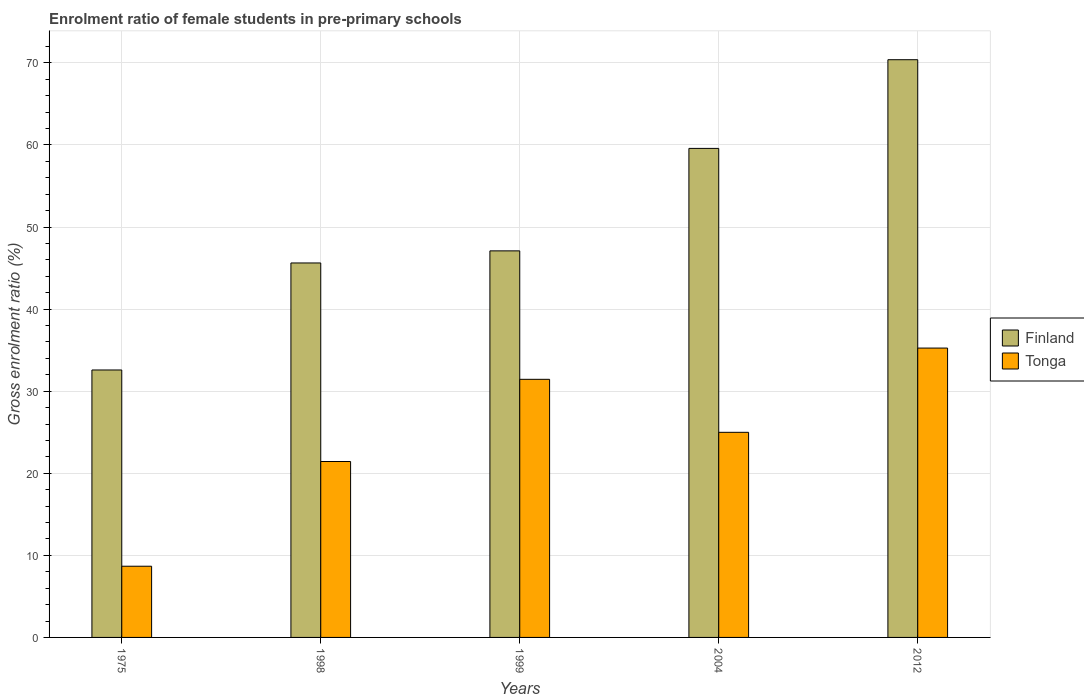How many groups of bars are there?
Give a very brief answer. 5. How many bars are there on the 1st tick from the left?
Provide a succinct answer. 2. How many bars are there on the 5th tick from the right?
Offer a very short reply. 2. What is the label of the 3rd group of bars from the left?
Give a very brief answer. 1999. What is the enrolment ratio of female students in pre-primary schools in Finland in 2004?
Your response must be concise. 59.58. Across all years, what is the maximum enrolment ratio of female students in pre-primary schools in Finland?
Provide a succinct answer. 70.39. Across all years, what is the minimum enrolment ratio of female students in pre-primary schools in Tonga?
Give a very brief answer. 8.67. In which year was the enrolment ratio of female students in pre-primary schools in Tonga minimum?
Ensure brevity in your answer.  1975. What is the total enrolment ratio of female students in pre-primary schools in Tonga in the graph?
Make the answer very short. 121.8. What is the difference between the enrolment ratio of female students in pre-primary schools in Finland in 1999 and that in 2012?
Provide a short and direct response. -23.29. What is the difference between the enrolment ratio of female students in pre-primary schools in Finland in 2012 and the enrolment ratio of female students in pre-primary schools in Tonga in 1999?
Provide a short and direct response. 38.94. What is the average enrolment ratio of female students in pre-primary schools in Tonga per year?
Keep it short and to the point. 24.36. In the year 1998, what is the difference between the enrolment ratio of female students in pre-primary schools in Tonga and enrolment ratio of female students in pre-primary schools in Finland?
Make the answer very short. -24.19. What is the ratio of the enrolment ratio of female students in pre-primary schools in Finland in 1975 to that in 1999?
Ensure brevity in your answer.  0.69. Is the enrolment ratio of female students in pre-primary schools in Finland in 1999 less than that in 2004?
Ensure brevity in your answer.  Yes. What is the difference between the highest and the second highest enrolment ratio of female students in pre-primary schools in Tonga?
Your answer should be compact. 3.81. What is the difference between the highest and the lowest enrolment ratio of female students in pre-primary schools in Tonga?
Offer a terse response. 26.58. In how many years, is the enrolment ratio of female students in pre-primary schools in Finland greater than the average enrolment ratio of female students in pre-primary schools in Finland taken over all years?
Your answer should be compact. 2. Is the sum of the enrolment ratio of female students in pre-primary schools in Finland in 1998 and 1999 greater than the maximum enrolment ratio of female students in pre-primary schools in Tonga across all years?
Your answer should be compact. Yes. What does the 2nd bar from the left in 1998 represents?
Your answer should be very brief. Tonga. Are all the bars in the graph horizontal?
Your answer should be very brief. No. What is the difference between two consecutive major ticks on the Y-axis?
Give a very brief answer. 10. Does the graph contain grids?
Your answer should be compact. Yes. How many legend labels are there?
Provide a short and direct response. 2. What is the title of the graph?
Give a very brief answer. Enrolment ratio of female students in pre-primary schools. Does "Macedonia" appear as one of the legend labels in the graph?
Ensure brevity in your answer.  No. What is the label or title of the Y-axis?
Ensure brevity in your answer.  Gross enrolment ratio (%). What is the Gross enrolment ratio (%) of Finland in 1975?
Make the answer very short. 32.59. What is the Gross enrolment ratio (%) of Tonga in 1975?
Offer a very short reply. 8.67. What is the Gross enrolment ratio (%) of Finland in 1998?
Ensure brevity in your answer.  45.63. What is the Gross enrolment ratio (%) of Tonga in 1998?
Offer a terse response. 21.43. What is the Gross enrolment ratio (%) in Finland in 1999?
Your answer should be compact. 47.1. What is the Gross enrolment ratio (%) in Tonga in 1999?
Offer a very short reply. 31.45. What is the Gross enrolment ratio (%) of Finland in 2004?
Provide a short and direct response. 59.58. What is the Gross enrolment ratio (%) of Tonga in 2004?
Keep it short and to the point. 24.99. What is the Gross enrolment ratio (%) in Finland in 2012?
Your answer should be compact. 70.39. What is the Gross enrolment ratio (%) of Tonga in 2012?
Your response must be concise. 35.26. Across all years, what is the maximum Gross enrolment ratio (%) in Finland?
Make the answer very short. 70.39. Across all years, what is the maximum Gross enrolment ratio (%) in Tonga?
Your answer should be very brief. 35.26. Across all years, what is the minimum Gross enrolment ratio (%) in Finland?
Provide a succinct answer. 32.59. Across all years, what is the minimum Gross enrolment ratio (%) in Tonga?
Your response must be concise. 8.67. What is the total Gross enrolment ratio (%) of Finland in the graph?
Give a very brief answer. 255.28. What is the total Gross enrolment ratio (%) of Tonga in the graph?
Your answer should be compact. 121.8. What is the difference between the Gross enrolment ratio (%) of Finland in 1975 and that in 1998?
Offer a very short reply. -13.04. What is the difference between the Gross enrolment ratio (%) in Tonga in 1975 and that in 1998?
Give a very brief answer. -12.76. What is the difference between the Gross enrolment ratio (%) of Finland in 1975 and that in 1999?
Offer a very short reply. -14.51. What is the difference between the Gross enrolment ratio (%) in Tonga in 1975 and that in 1999?
Offer a very short reply. -22.77. What is the difference between the Gross enrolment ratio (%) in Finland in 1975 and that in 2004?
Provide a short and direct response. -27. What is the difference between the Gross enrolment ratio (%) of Tonga in 1975 and that in 2004?
Ensure brevity in your answer.  -16.32. What is the difference between the Gross enrolment ratio (%) of Finland in 1975 and that in 2012?
Ensure brevity in your answer.  -37.8. What is the difference between the Gross enrolment ratio (%) of Tonga in 1975 and that in 2012?
Offer a very short reply. -26.58. What is the difference between the Gross enrolment ratio (%) in Finland in 1998 and that in 1999?
Ensure brevity in your answer.  -1.47. What is the difference between the Gross enrolment ratio (%) of Tonga in 1998 and that in 1999?
Keep it short and to the point. -10.01. What is the difference between the Gross enrolment ratio (%) in Finland in 1998 and that in 2004?
Give a very brief answer. -13.96. What is the difference between the Gross enrolment ratio (%) in Tonga in 1998 and that in 2004?
Make the answer very short. -3.56. What is the difference between the Gross enrolment ratio (%) of Finland in 1998 and that in 2012?
Your response must be concise. -24.76. What is the difference between the Gross enrolment ratio (%) of Tonga in 1998 and that in 2012?
Provide a succinct answer. -13.82. What is the difference between the Gross enrolment ratio (%) of Finland in 1999 and that in 2004?
Offer a very short reply. -12.48. What is the difference between the Gross enrolment ratio (%) in Tonga in 1999 and that in 2004?
Ensure brevity in your answer.  6.46. What is the difference between the Gross enrolment ratio (%) in Finland in 1999 and that in 2012?
Keep it short and to the point. -23.29. What is the difference between the Gross enrolment ratio (%) in Tonga in 1999 and that in 2012?
Ensure brevity in your answer.  -3.81. What is the difference between the Gross enrolment ratio (%) in Finland in 2004 and that in 2012?
Provide a short and direct response. -10.81. What is the difference between the Gross enrolment ratio (%) in Tonga in 2004 and that in 2012?
Make the answer very short. -10.27. What is the difference between the Gross enrolment ratio (%) in Finland in 1975 and the Gross enrolment ratio (%) in Tonga in 1998?
Keep it short and to the point. 11.15. What is the difference between the Gross enrolment ratio (%) in Finland in 1975 and the Gross enrolment ratio (%) in Tonga in 1999?
Ensure brevity in your answer.  1.14. What is the difference between the Gross enrolment ratio (%) of Finland in 1975 and the Gross enrolment ratio (%) of Tonga in 2004?
Provide a short and direct response. 7.6. What is the difference between the Gross enrolment ratio (%) in Finland in 1975 and the Gross enrolment ratio (%) in Tonga in 2012?
Make the answer very short. -2.67. What is the difference between the Gross enrolment ratio (%) of Finland in 1998 and the Gross enrolment ratio (%) of Tonga in 1999?
Make the answer very short. 14.18. What is the difference between the Gross enrolment ratio (%) of Finland in 1998 and the Gross enrolment ratio (%) of Tonga in 2004?
Ensure brevity in your answer.  20.64. What is the difference between the Gross enrolment ratio (%) in Finland in 1998 and the Gross enrolment ratio (%) in Tonga in 2012?
Offer a very short reply. 10.37. What is the difference between the Gross enrolment ratio (%) in Finland in 1999 and the Gross enrolment ratio (%) in Tonga in 2004?
Provide a short and direct response. 22.11. What is the difference between the Gross enrolment ratio (%) in Finland in 1999 and the Gross enrolment ratio (%) in Tonga in 2012?
Your response must be concise. 11.84. What is the difference between the Gross enrolment ratio (%) of Finland in 2004 and the Gross enrolment ratio (%) of Tonga in 2012?
Your answer should be compact. 24.33. What is the average Gross enrolment ratio (%) of Finland per year?
Ensure brevity in your answer.  51.06. What is the average Gross enrolment ratio (%) of Tonga per year?
Provide a succinct answer. 24.36. In the year 1975, what is the difference between the Gross enrolment ratio (%) of Finland and Gross enrolment ratio (%) of Tonga?
Offer a terse response. 23.91. In the year 1998, what is the difference between the Gross enrolment ratio (%) in Finland and Gross enrolment ratio (%) in Tonga?
Ensure brevity in your answer.  24.19. In the year 1999, what is the difference between the Gross enrolment ratio (%) of Finland and Gross enrolment ratio (%) of Tonga?
Ensure brevity in your answer.  15.65. In the year 2004, what is the difference between the Gross enrolment ratio (%) in Finland and Gross enrolment ratio (%) in Tonga?
Give a very brief answer. 34.59. In the year 2012, what is the difference between the Gross enrolment ratio (%) in Finland and Gross enrolment ratio (%) in Tonga?
Your response must be concise. 35.13. What is the ratio of the Gross enrolment ratio (%) of Finland in 1975 to that in 1998?
Your response must be concise. 0.71. What is the ratio of the Gross enrolment ratio (%) in Tonga in 1975 to that in 1998?
Provide a short and direct response. 0.4. What is the ratio of the Gross enrolment ratio (%) of Finland in 1975 to that in 1999?
Your answer should be compact. 0.69. What is the ratio of the Gross enrolment ratio (%) of Tonga in 1975 to that in 1999?
Your response must be concise. 0.28. What is the ratio of the Gross enrolment ratio (%) of Finland in 1975 to that in 2004?
Make the answer very short. 0.55. What is the ratio of the Gross enrolment ratio (%) of Tonga in 1975 to that in 2004?
Give a very brief answer. 0.35. What is the ratio of the Gross enrolment ratio (%) in Finland in 1975 to that in 2012?
Your answer should be compact. 0.46. What is the ratio of the Gross enrolment ratio (%) of Tonga in 1975 to that in 2012?
Your answer should be very brief. 0.25. What is the ratio of the Gross enrolment ratio (%) of Finland in 1998 to that in 1999?
Ensure brevity in your answer.  0.97. What is the ratio of the Gross enrolment ratio (%) in Tonga in 1998 to that in 1999?
Offer a very short reply. 0.68. What is the ratio of the Gross enrolment ratio (%) in Finland in 1998 to that in 2004?
Provide a succinct answer. 0.77. What is the ratio of the Gross enrolment ratio (%) in Tonga in 1998 to that in 2004?
Offer a terse response. 0.86. What is the ratio of the Gross enrolment ratio (%) of Finland in 1998 to that in 2012?
Your response must be concise. 0.65. What is the ratio of the Gross enrolment ratio (%) in Tonga in 1998 to that in 2012?
Provide a succinct answer. 0.61. What is the ratio of the Gross enrolment ratio (%) in Finland in 1999 to that in 2004?
Give a very brief answer. 0.79. What is the ratio of the Gross enrolment ratio (%) in Tonga in 1999 to that in 2004?
Your response must be concise. 1.26. What is the ratio of the Gross enrolment ratio (%) in Finland in 1999 to that in 2012?
Your answer should be compact. 0.67. What is the ratio of the Gross enrolment ratio (%) in Tonga in 1999 to that in 2012?
Your answer should be compact. 0.89. What is the ratio of the Gross enrolment ratio (%) in Finland in 2004 to that in 2012?
Provide a succinct answer. 0.85. What is the ratio of the Gross enrolment ratio (%) of Tonga in 2004 to that in 2012?
Your answer should be very brief. 0.71. What is the difference between the highest and the second highest Gross enrolment ratio (%) of Finland?
Offer a terse response. 10.81. What is the difference between the highest and the second highest Gross enrolment ratio (%) of Tonga?
Give a very brief answer. 3.81. What is the difference between the highest and the lowest Gross enrolment ratio (%) in Finland?
Your answer should be compact. 37.8. What is the difference between the highest and the lowest Gross enrolment ratio (%) in Tonga?
Provide a short and direct response. 26.58. 